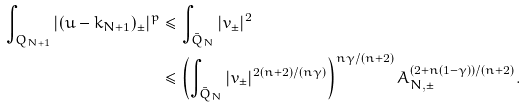Convert formula to latex. <formula><loc_0><loc_0><loc_500><loc_500>\int _ { Q _ { N + 1 } } | ( u - k _ { N + 1 } ) _ { \pm } | ^ { p } & \leq \int _ { \bar { Q } _ { N } } | v _ { \pm } | ^ { 2 } \\ & \leq \left ( \int _ { \bar { Q } _ { N } } | v _ { \pm } | ^ { 2 ( n + 2 ) / ( n \gamma ) } \right ) ^ { n \gamma / ( n + 2 ) } A _ { N , \pm } ^ { ( 2 + n ( 1 - \gamma ) ) / ( n + 2 ) } .</formula> 